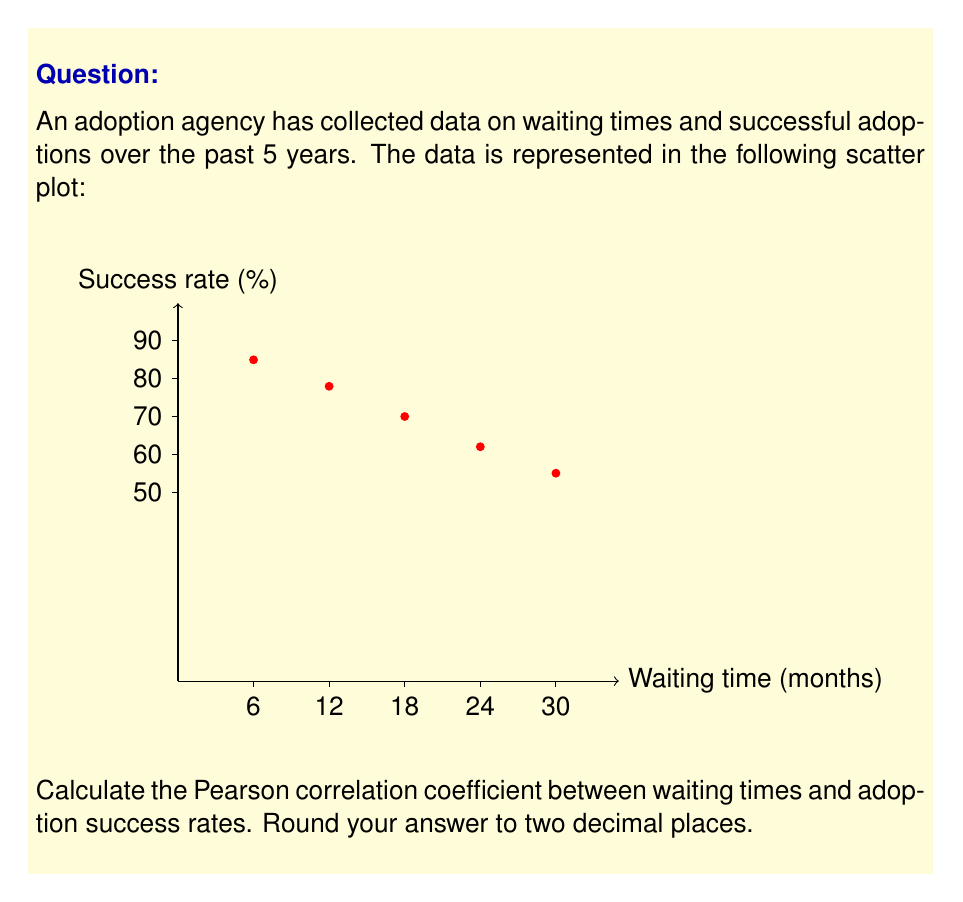Show me your answer to this math problem. To calculate the Pearson correlation coefficient, we'll use the formula:

$$ r = \frac{\sum_{i=1}^{n} (x_i - \bar{x})(y_i - \bar{y})}{\sqrt{\sum_{i=1}^{n} (x_i - \bar{x})^2 \sum_{i=1}^{n} (y_i - \bar{y})^2}} $$

Where:
$x_i$ are the waiting times
$y_i$ are the success rates
$\bar{x}$ is the mean of waiting times
$\bar{y}$ is the mean of success rates

Step 1: Calculate means
$\bar{x} = \frac{6 + 12 + 18 + 24 + 30}{5} = 18$
$\bar{y} = \frac{85 + 78 + 70 + 62 + 55}{5} = 70$

Step 2: Calculate $(x_i - \bar{x})$, $(y_i - \bar{y})$, $(x_i - \bar{x})^2$, $(y_i - \bar{y})^2$, and $(x_i - \bar{x})(y_i - \bar{y})$

| $x_i$ | $y_i$ | $x_i - \bar{x}$ | $y_i - \bar{y}$ | $(x_i - \bar{x})^2$ | $(y_i - \bar{y})^2$ | $(x_i - \bar{x})(y_i - \bar{y})$ |
|-------|-------|-----------------|-----------------|---------------------|---------------------|----------------------------------|
| 6     | 85    | -12             | 15              | 144                 | 225                 | -180                             |
| 12    | 78    | -6              | 8               | 36                  | 64                  | -48                              |
| 18    | 70    | 0               | 0               | 0                   | 0                   | 0                                |
| 24    | 62    | 6               | -8              | 36                  | 64                  | -48                              |
| 30    | 55    | 12              | -15             | 144                 | 225                 | -180                             |

Step 3: Sum the last three columns
$\sum (x_i - \bar{x})^2 = 360$
$\sum (y_i - \bar{y})^2 = 578$
$\sum (x_i - \bar{x})(y_i - \bar{y}) = -456$

Step 4: Apply the formula
$$ r = \frac{-456}{\sqrt{360 \cdot 578}} = \frac{-456}{\sqrt{208080}} = \frac{-456}{456.1578} \approx -0.9996 $$

Step 5: Round to two decimal places
$r \approx -1.00$
Answer: $-1.00$ 